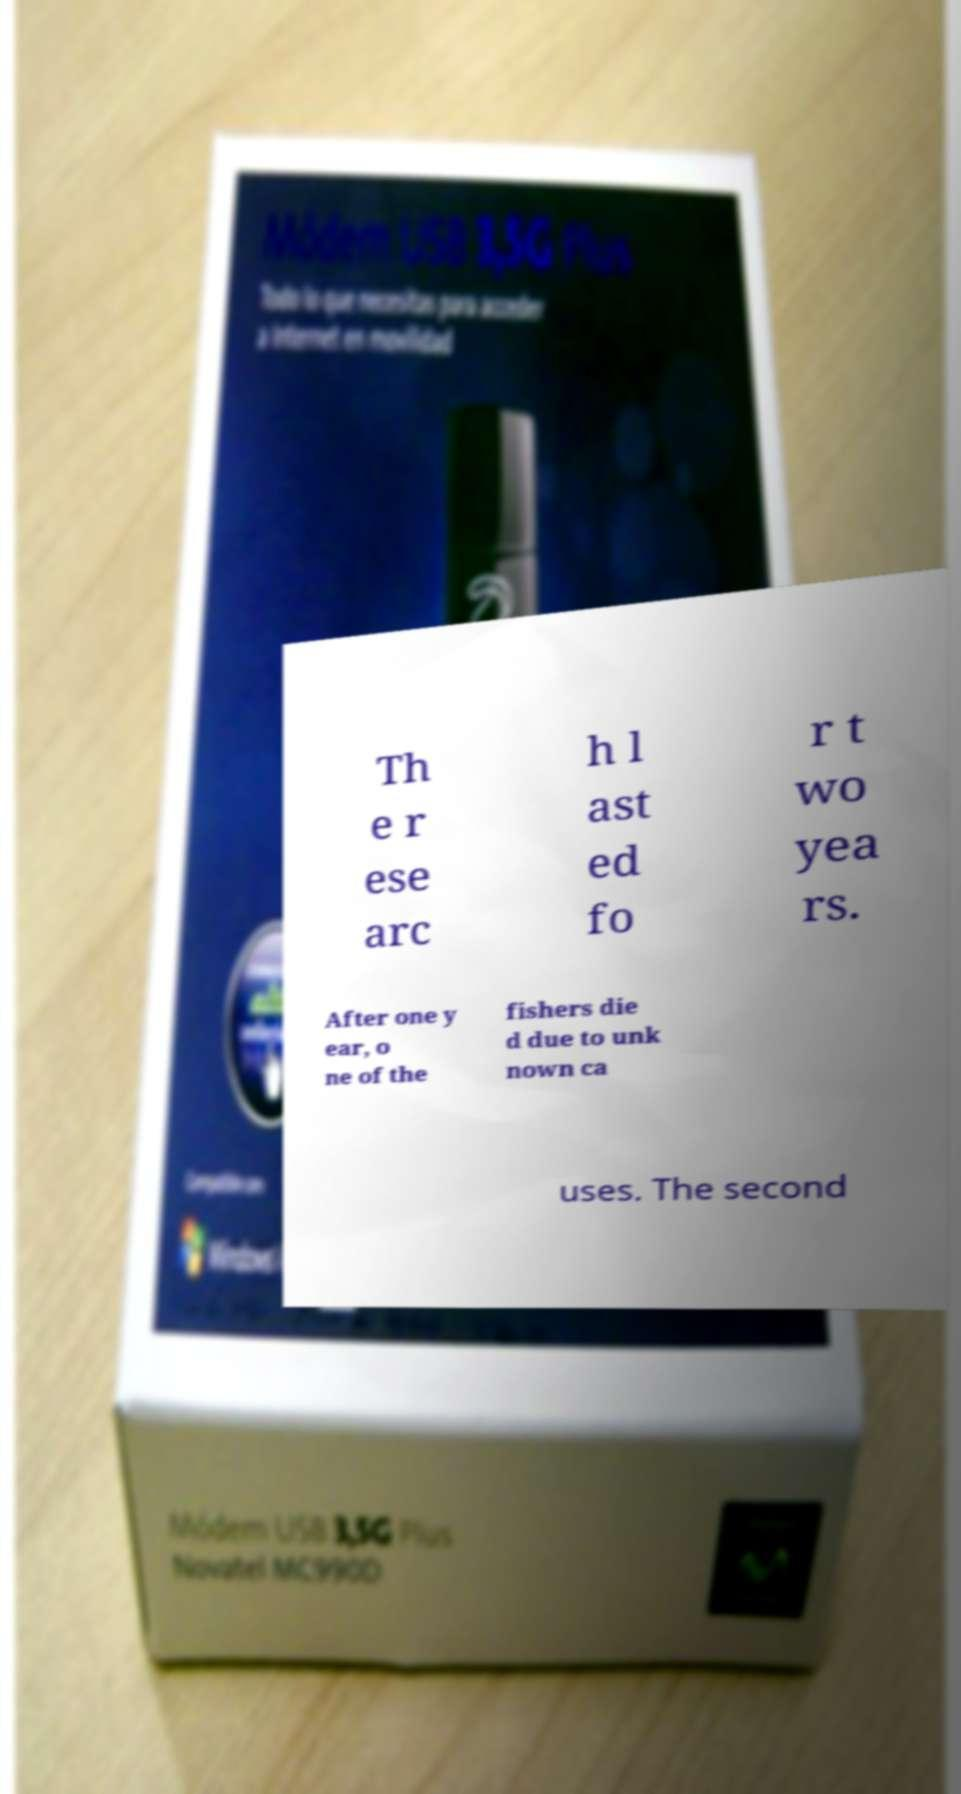Can you accurately transcribe the text from the provided image for me? Th e r ese arc h l ast ed fo r t wo yea rs. After one y ear, o ne of the fishers die d due to unk nown ca uses. The second 